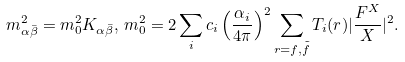Convert formula to latex. <formula><loc_0><loc_0><loc_500><loc_500>m _ { \alpha \bar { \beta } } ^ { 2 } = m _ { 0 } ^ { 2 } K _ { \alpha \bar { \beta } } , \, m _ { 0 } ^ { 2 } = 2 \sum _ { i } c _ { i } \left ( \frac { \alpha _ { i } } { 4 \pi } \right ) ^ { 2 } \sum _ { r = f , \tilde { f } } T _ { i } ( r ) | \frac { F ^ { X } } { X } | ^ { 2 } .</formula> 